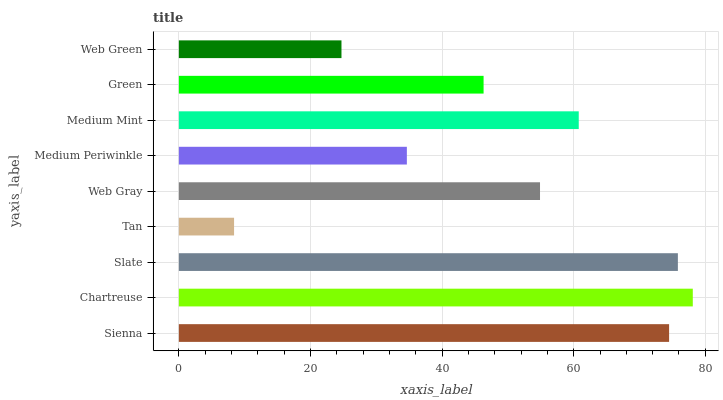Is Tan the minimum?
Answer yes or no. Yes. Is Chartreuse the maximum?
Answer yes or no. Yes. Is Slate the minimum?
Answer yes or no. No. Is Slate the maximum?
Answer yes or no. No. Is Chartreuse greater than Slate?
Answer yes or no. Yes. Is Slate less than Chartreuse?
Answer yes or no. Yes. Is Slate greater than Chartreuse?
Answer yes or no. No. Is Chartreuse less than Slate?
Answer yes or no. No. Is Web Gray the high median?
Answer yes or no. Yes. Is Web Gray the low median?
Answer yes or no. Yes. Is Web Green the high median?
Answer yes or no. No. Is Chartreuse the low median?
Answer yes or no. No. 